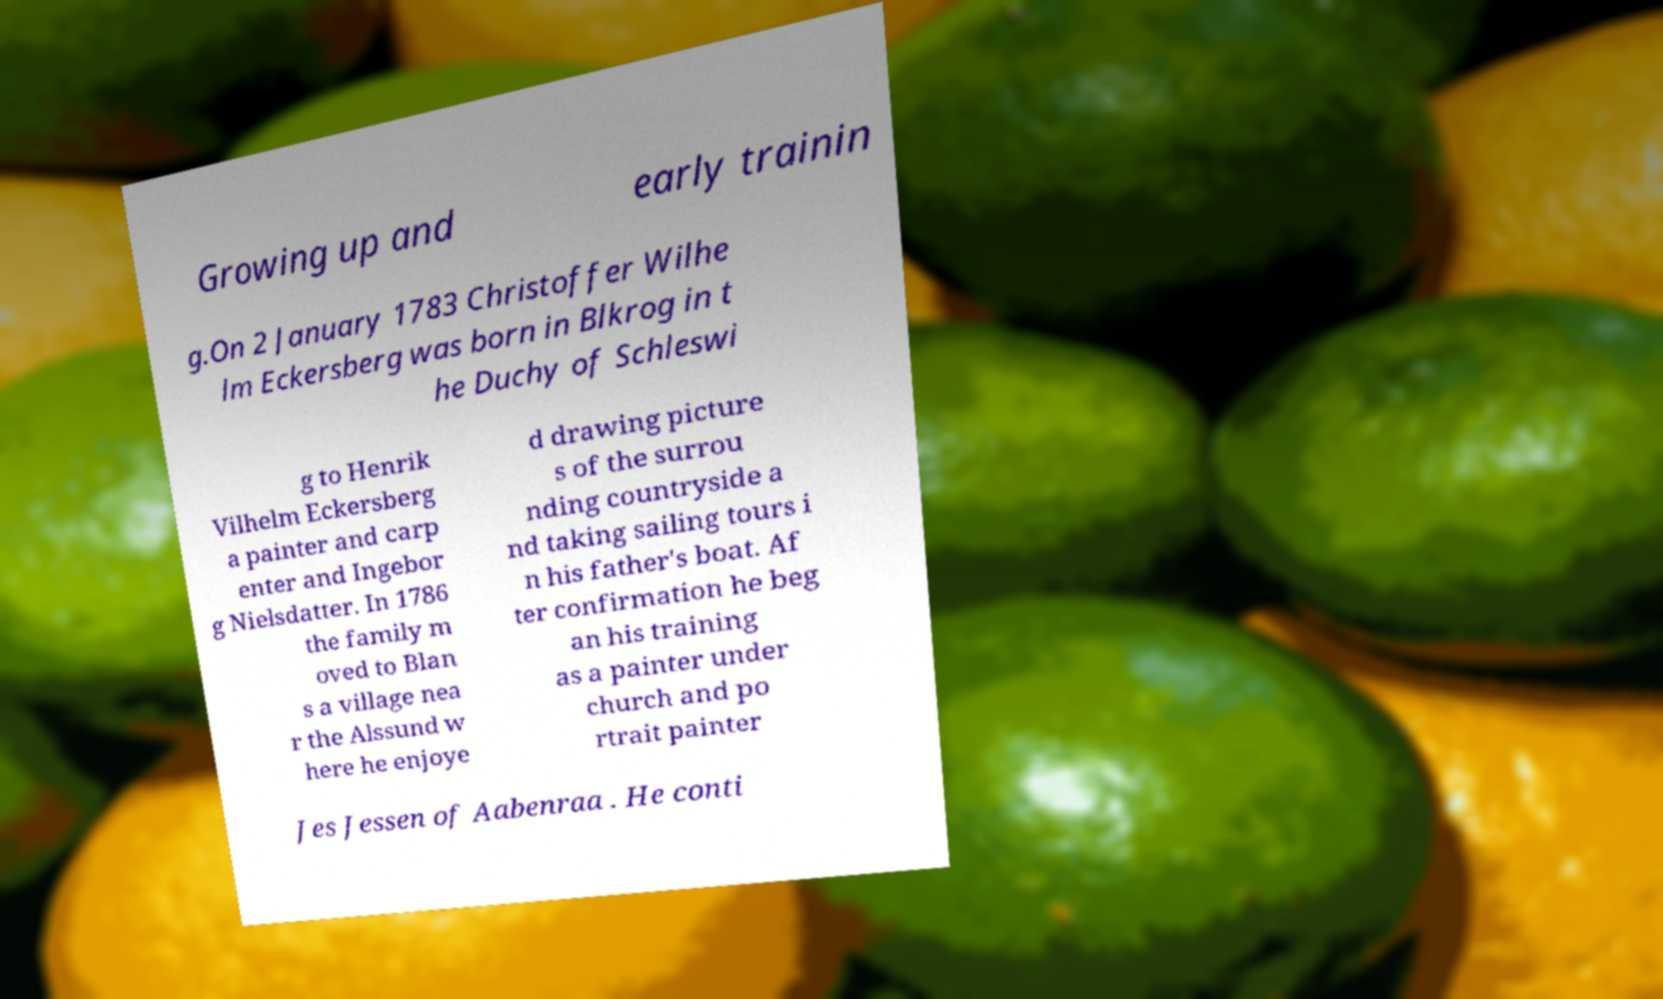Could you extract and type out the text from this image? Growing up and early trainin g.On 2 January 1783 Christoffer Wilhe lm Eckersberg was born in Blkrog in t he Duchy of Schleswi g to Henrik Vilhelm Eckersberg a painter and carp enter and Ingebor g Nielsdatter. In 1786 the family m oved to Blan s a village nea r the Alssund w here he enjoye d drawing picture s of the surrou nding countryside a nd taking sailing tours i n his father's boat. Af ter confirmation he beg an his training as a painter under church and po rtrait painter Jes Jessen of Aabenraa . He conti 